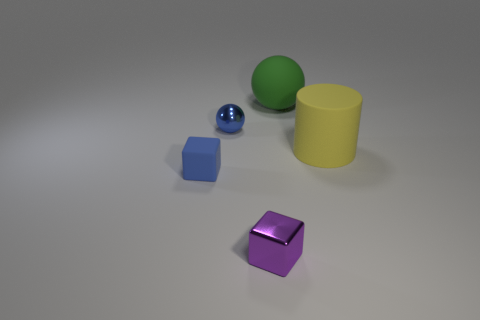Add 4 small gray blocks. How many objects exist? 9 Subtract all cubes. How many objects are left? 3 Subtract all blue spheres. Subtract all tiny blue cubes. How many objects are left? 3 Add 4 green objects. How many green objects are left? 5 Add 5 purple metallic objects. How many purple metallic objects exist? 6 Subtract 1 yellow cylinders. How many objects are left? 4 